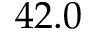Convert formula to latex. <formula><loc_0><loc_0><loc_500><loc_500>4 2 . 0</formula> 